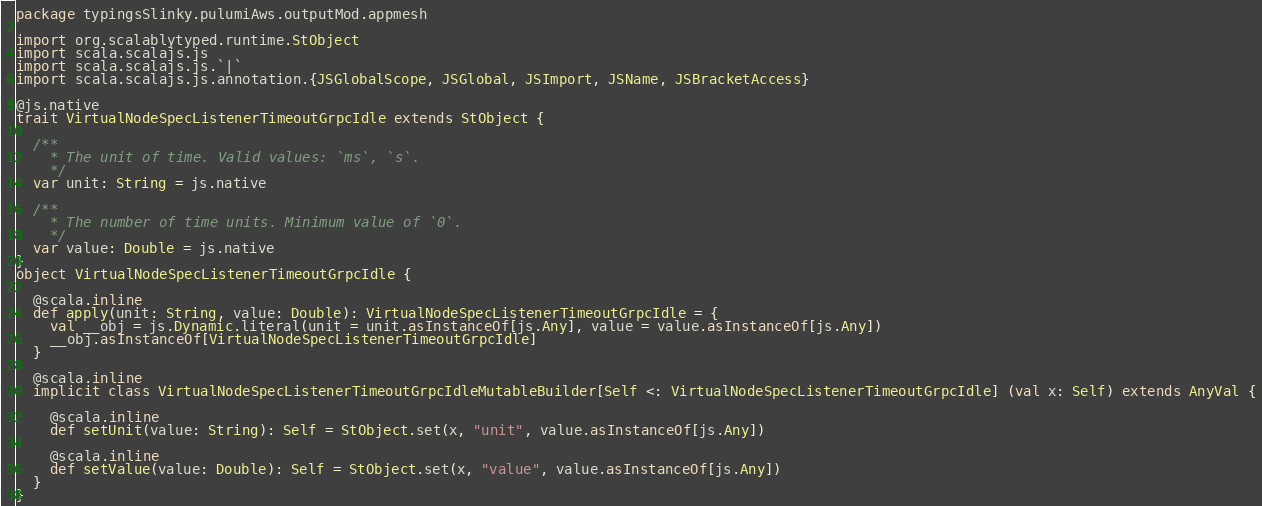<code> <loc_0><loc_0><loc_500><loc_500><_Scala_>package typingsSlinky.pulumiAws.outputMod.appmesh

import org.scalablytyped.runtime.StObject
import scala.scalajs.js
import scala.scalajs.js.`|`
import scala.scalajs.js.annotation.{JSGlobalScope, JSGlobal, JSImport, JSName, JSBracketAccess}

@js.native
trait VirtualNodeSpecListenerTimeoutGrpcIdle extends StObject {
  
  /**
    * The unit of time. Valid values: `ms`, `s`.
    */
  var unit: String = js.native
  
  /**
    * The number of time units. Minimum value of `0`.
    */
  var value: Double = js.native
}
object VirtualNodeSpecListenerTimeoutGrpcIdle {
  
  @scala.inline
  def apply(unit: String, value: Double): VirtualNodeSpecListenerTimeoutGrpcIdle = {
    val __obj = js.Dynamic.literal(unit = unit.asInstanceOf[js.Any], value = value.asInstanceOf[js.Any])
    __obj.asInstanceOf[VirtualNodeSpecListenerTimeoutGrpcIdle]
  }
  
  @scala.inline
  implicit class VirtualNodeSpecListenerTimeoutGrpcIdleMutableBuilder[Self <: VirtualNodeSpecListenerTimeoutGrpcIdle] (val x: Self) extends AnyVal {
    
    @scala.inline
    def setUnit(value: String): Self = StObject.set(x, "unit", value.asInstanceOf[js.Any])
    
    @scala.inline
    def setValue(value: Double): Self = StObject.set(x, "value", value.asInstanceOf[js.Any])
  }
}
</code> 